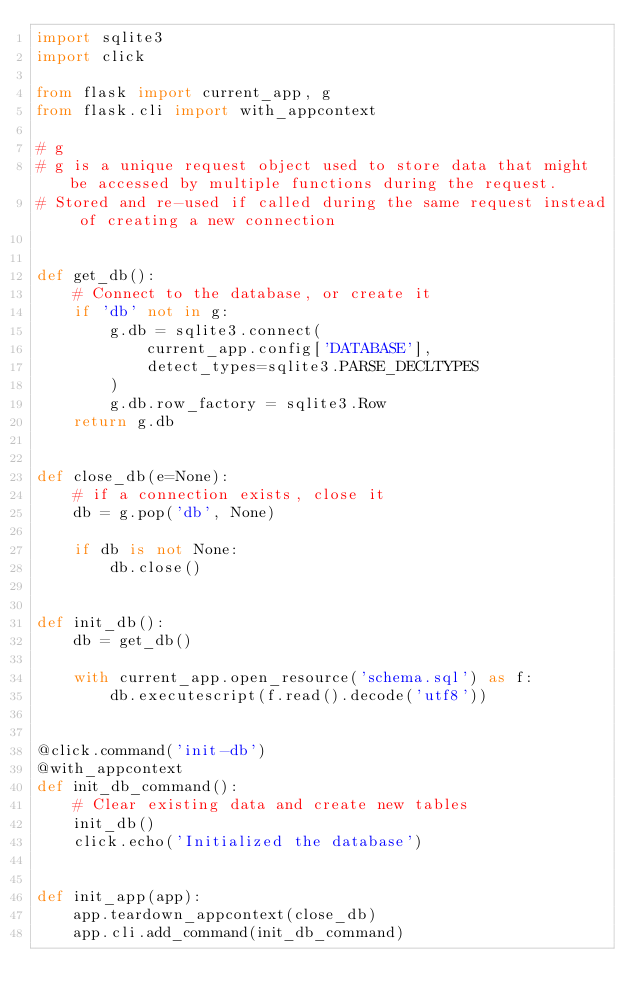Convert code to text. <code><loc_0><loc_0><loc_500><loc_500><_Python_>import sqlite3
import click

from flask import current_app, g
from flask.cli import with_appcontext

# g
# g is a unique request object used to store data that might be accessed by multiple functions during the request.
# Stored and re-used if called during the same request instead of creating a new connection


def get_db():
    # Connect to the database, or create it
    if 'db' not in g:
        g.db = sqlite3.connect(
            current_app.config['DATABASE'],
            detect_types=sqlite3.PARSE_DECLTYPES
        )
        g.db.row_factory = sqlite3.Row
    return g.db


def close_db(e=None):
    # if a connection exists, close it
    db = g.pop('db', None)

    if db is not None:
        db.close()


def init_db():
    db = get_db()

    with current_app.open_resource('schema.sql') as f:
        db.executescript(f.read().decode('utf8'))


@click.command('init-db')
@with_appcontext
def init_db_command():
    # Clear existing data and create new tables
    init_db()
    click.echo('Initialized the database')


def init_app(app):
    app.teardown_appcontext(close_db)
    app.cli.add_command(init_db_command)
</code> 